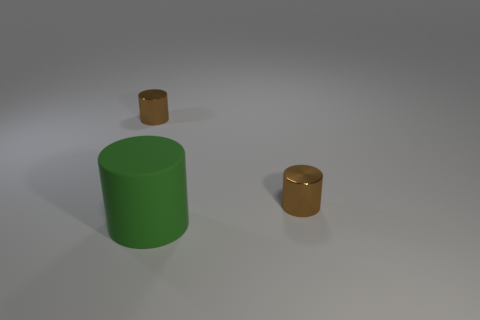Add 2 small matte objects. How many objects exist? 5 Add 2 large green things. How many large green things are left? 3 Add 3 shiny things. How many shiny things exist? 5 Subtract 0 cyan cylinders. How many objects are left? 3 Subtract all brown metal cylinders. Subtract all large green cylinders. How many objects are left? 0 